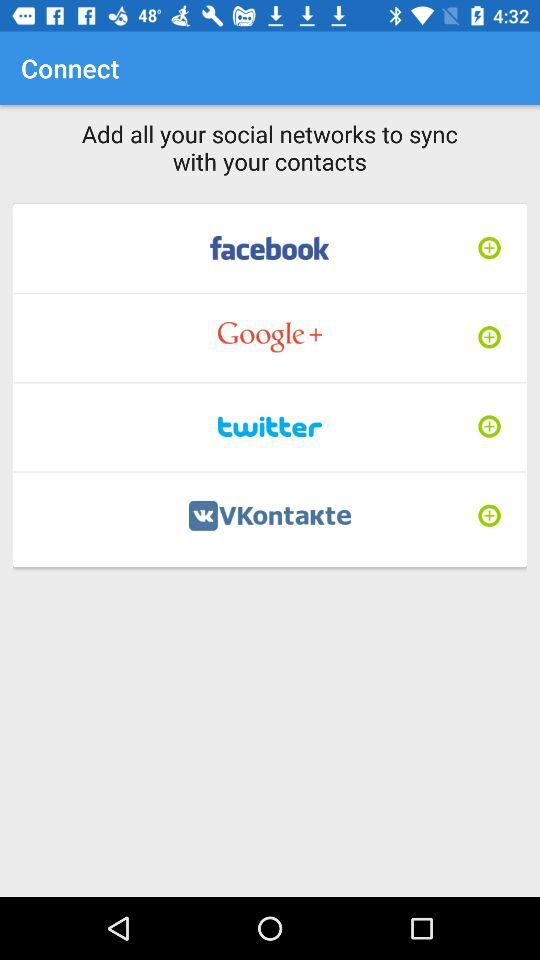What are the options available for the synchronization of contacts? The available options are "facebook", "Google +", "twitter" and "VKontakte". 